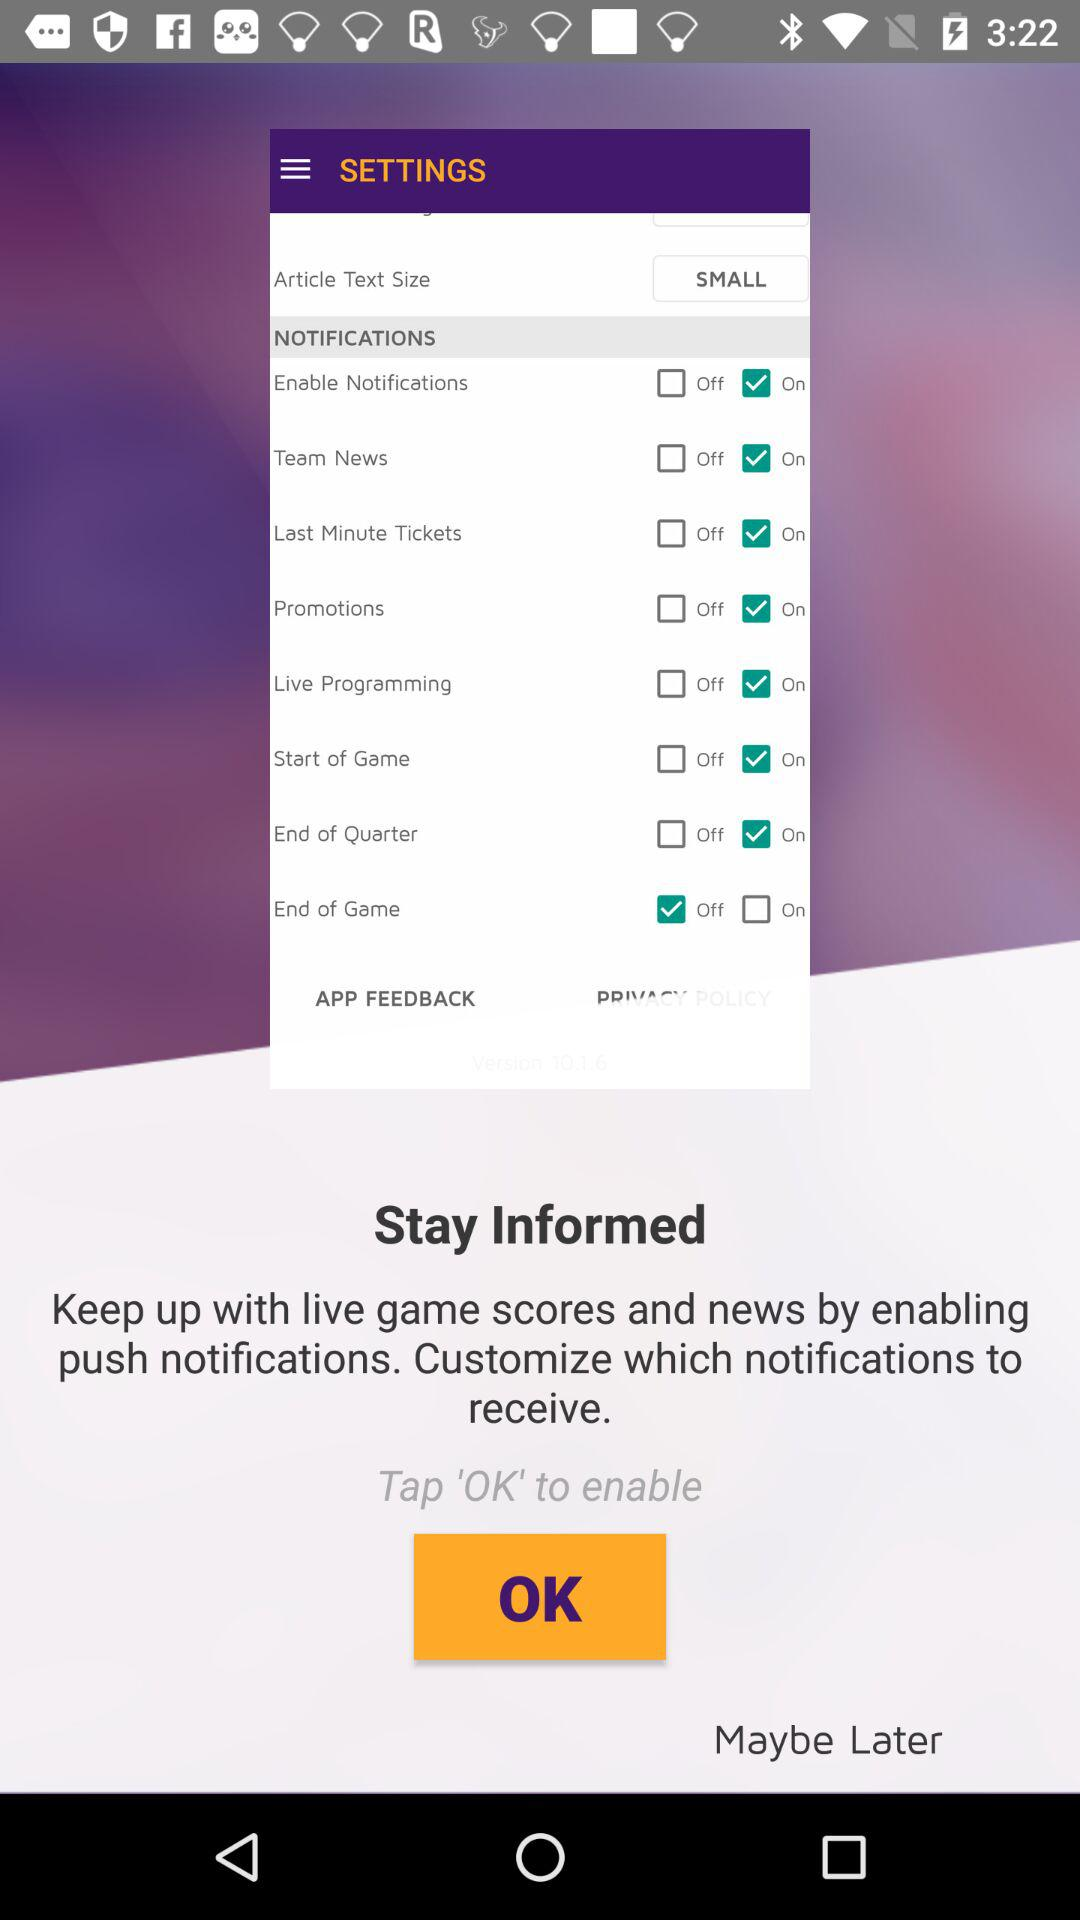What are the available notification options in the list? The available options are "Enable Notifications", "Team News", "Last Minute Tickets", "Promotions", "Live Programming", "Start of Game", "End of Quarter", and "End of Game". 